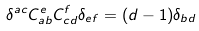Convert formula to latex. <formula><loc_0><loc_0><loc_500><loc_500>\delta ^ { a c } C _ { a b } ^ { e } C _ { c d } ^ { f } \delta _ { e f } = ( d - 1 ) \delta _ { b d }</formula> 